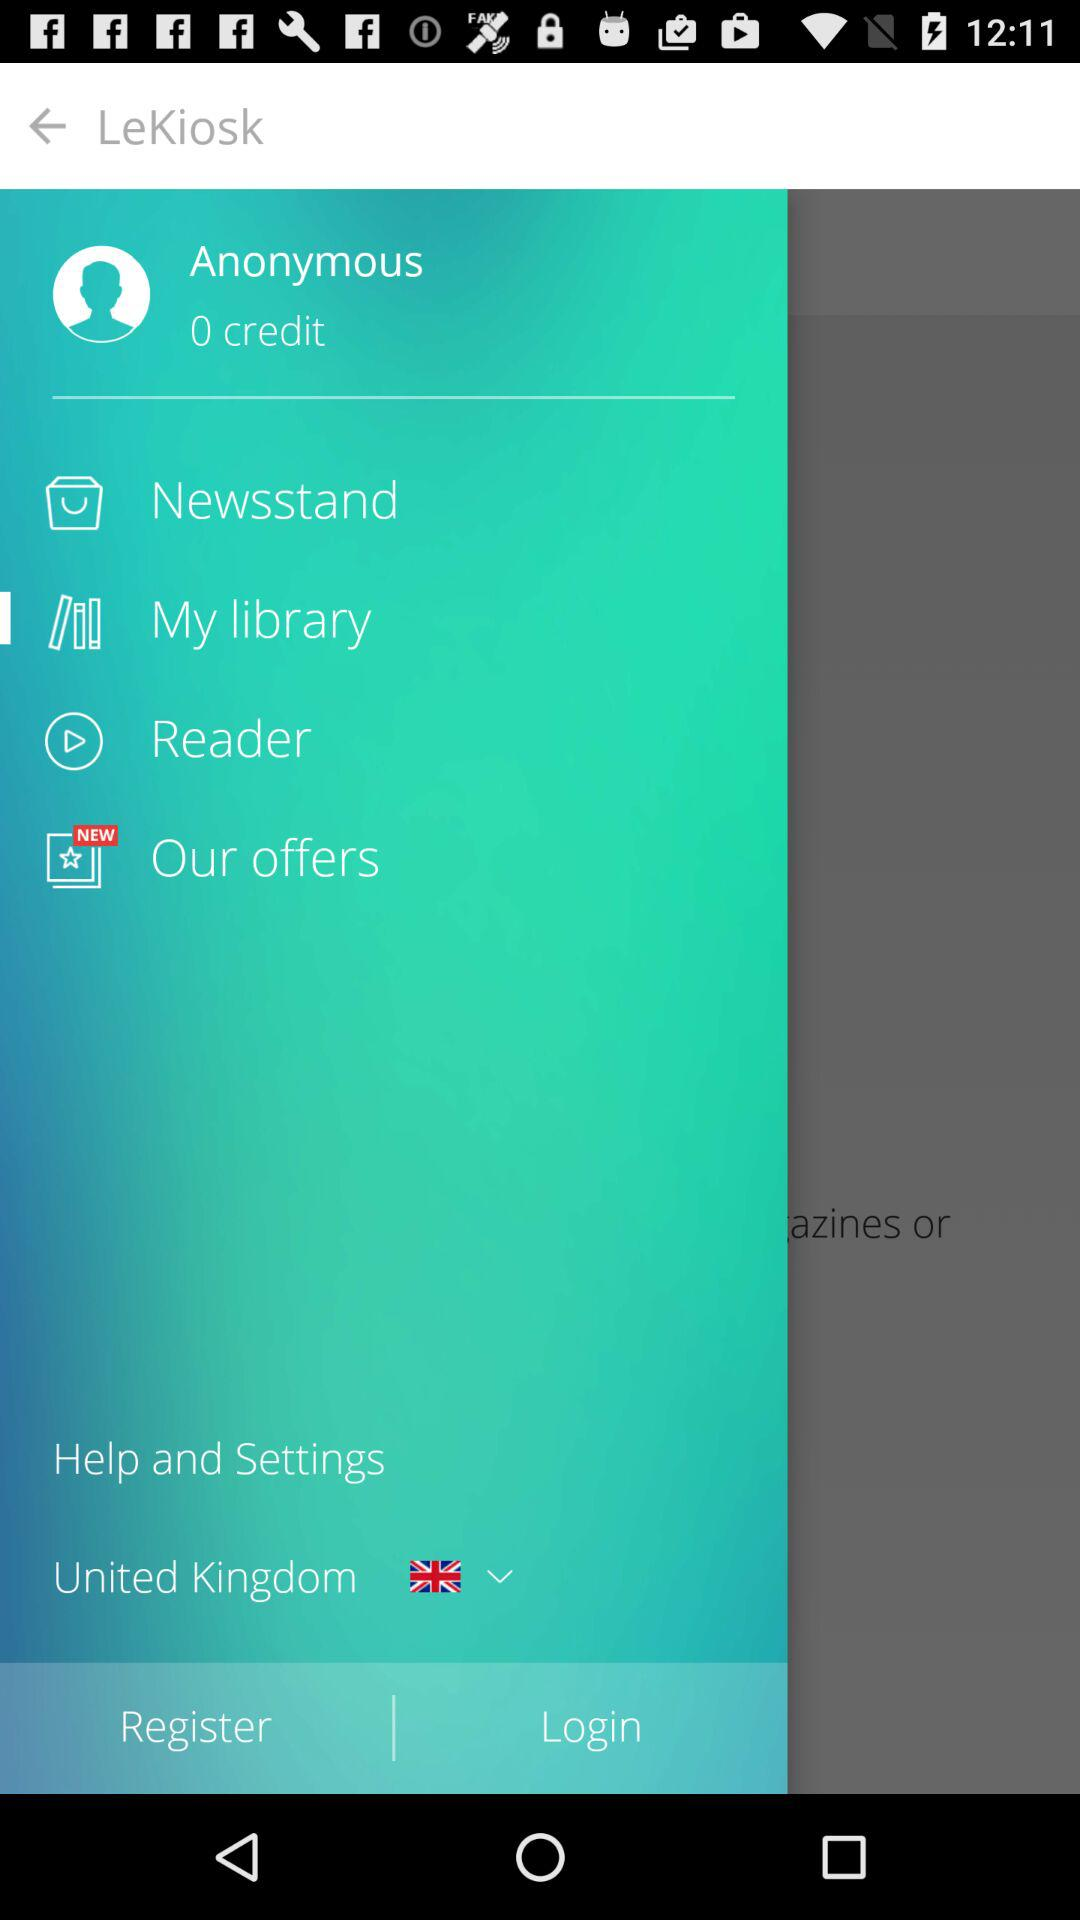Which country is selected? The selected country is the United Kingdom. 